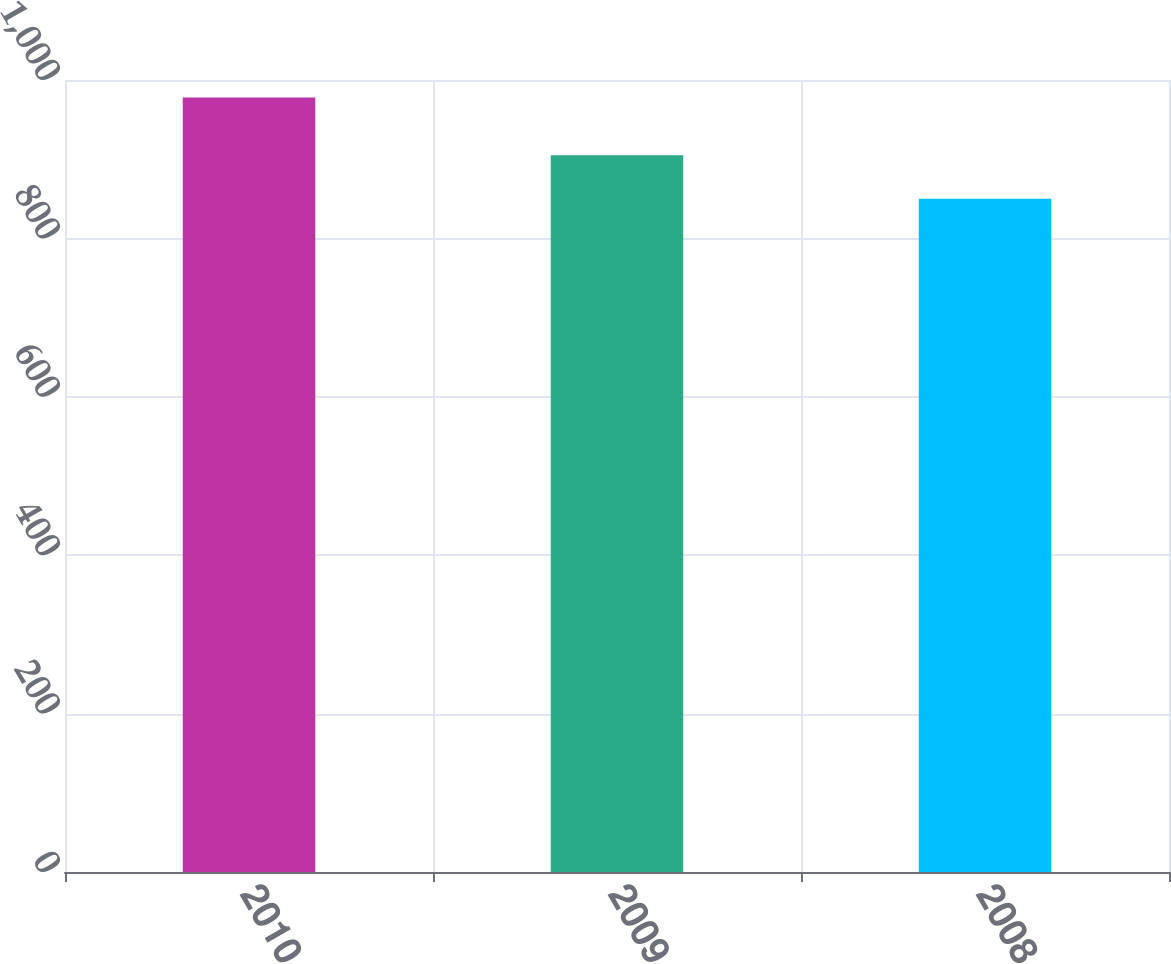Convert chart to OTSL. <chart><loc_0><loc_0><loc_500><loc_500><bar_chart><fcel>2010<fcel>2009<fcel>2008<nl><fcel>978<fcel>905<fcel>850<nl></chart> 